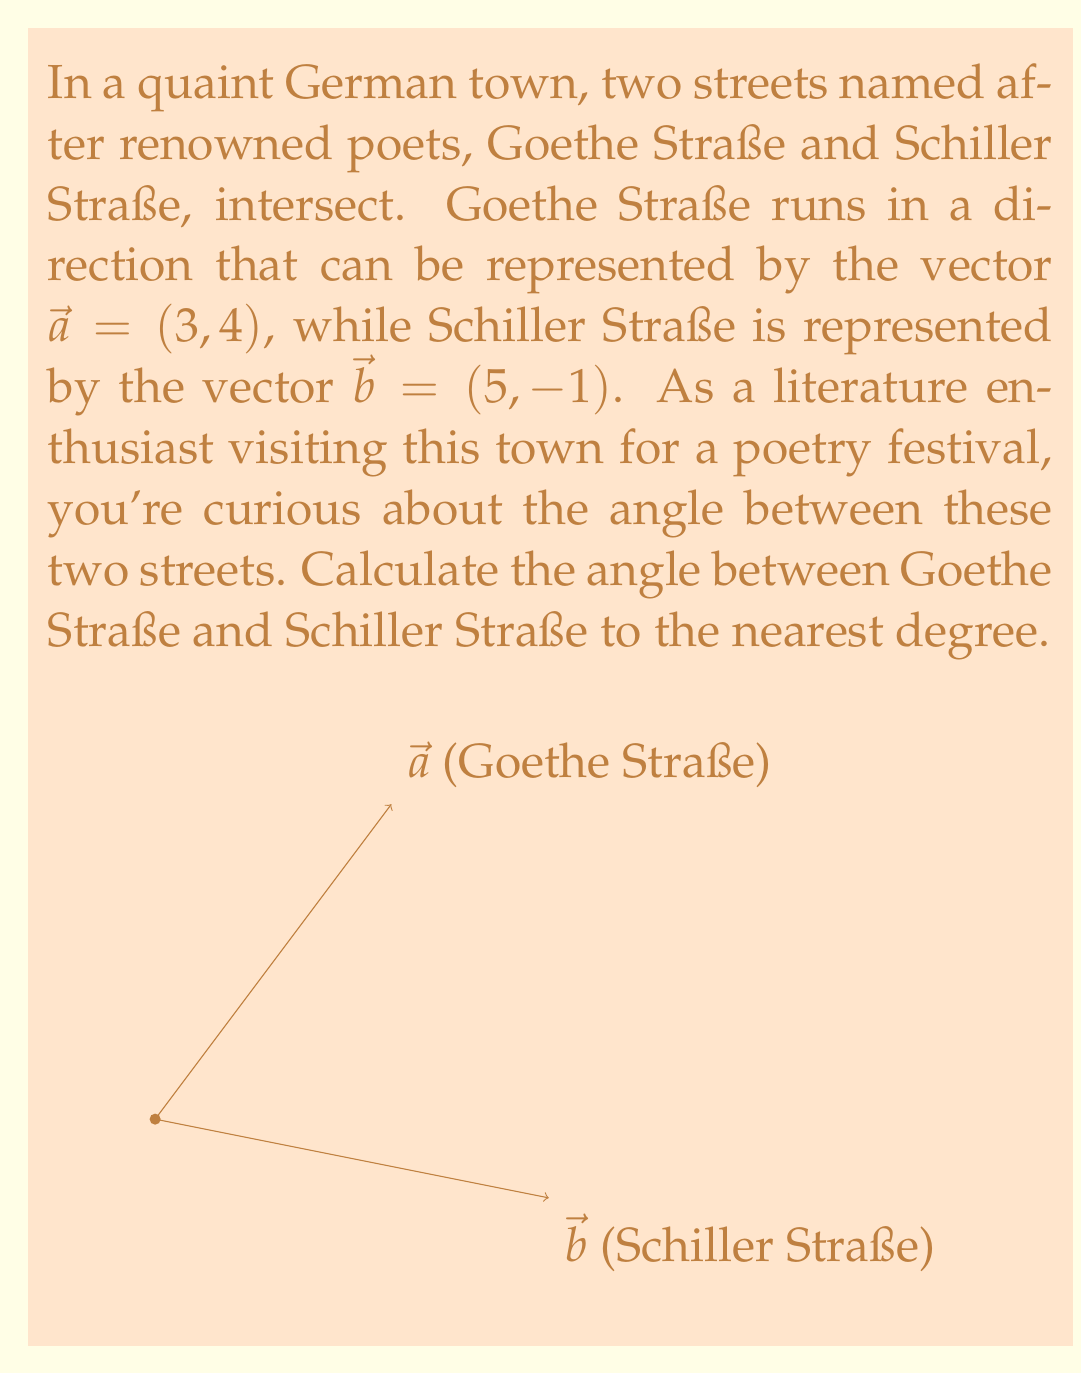Provide a solution to this math problem. To find the angle between two vectors, we can use the dot product formula:

$$\cos \theta = \frac{\vec{a} \cdot \vec{b}}{|\vec{a}||\vec{b}|}$$

Let's solve this step-by-step:

1) First, calculate the dot product $\vec{a} \cdot \vec{b}$:
   $$\vec{a} \cdot \vec{b} = (3)(5) + (4)(-1) = 15 - 4 = 11$$

2) Calculate the magnitudes of the vectors:
   $$|\vec{a}| = \sqrt{3^2 + 4^2} = \sqrt{9 + 16} = \sqrt{25} = 5$$
   $$|\vec{b}| = \sqrt{5^2 + (-1)^2} = \sqrt{25 + 1} = \sqrt{26}$$

3) Now, substitute these values into the formula:
   $$\cos \theta = \frac{11}{5\sqrt{26}}$$

4) To find $\theta$, we need to take the inverse cosine (arccos) of both sides:
   $$\theta = \arccos(\frac{11}{5\sqrt{26}})$$

5) Using a calculator and rounding to the nearest degree:
   $$\theta \approx 66°$$

Thus, the angle between Goethe Straße and Schiller Straße is approximately 66°.
Answer: 66° 